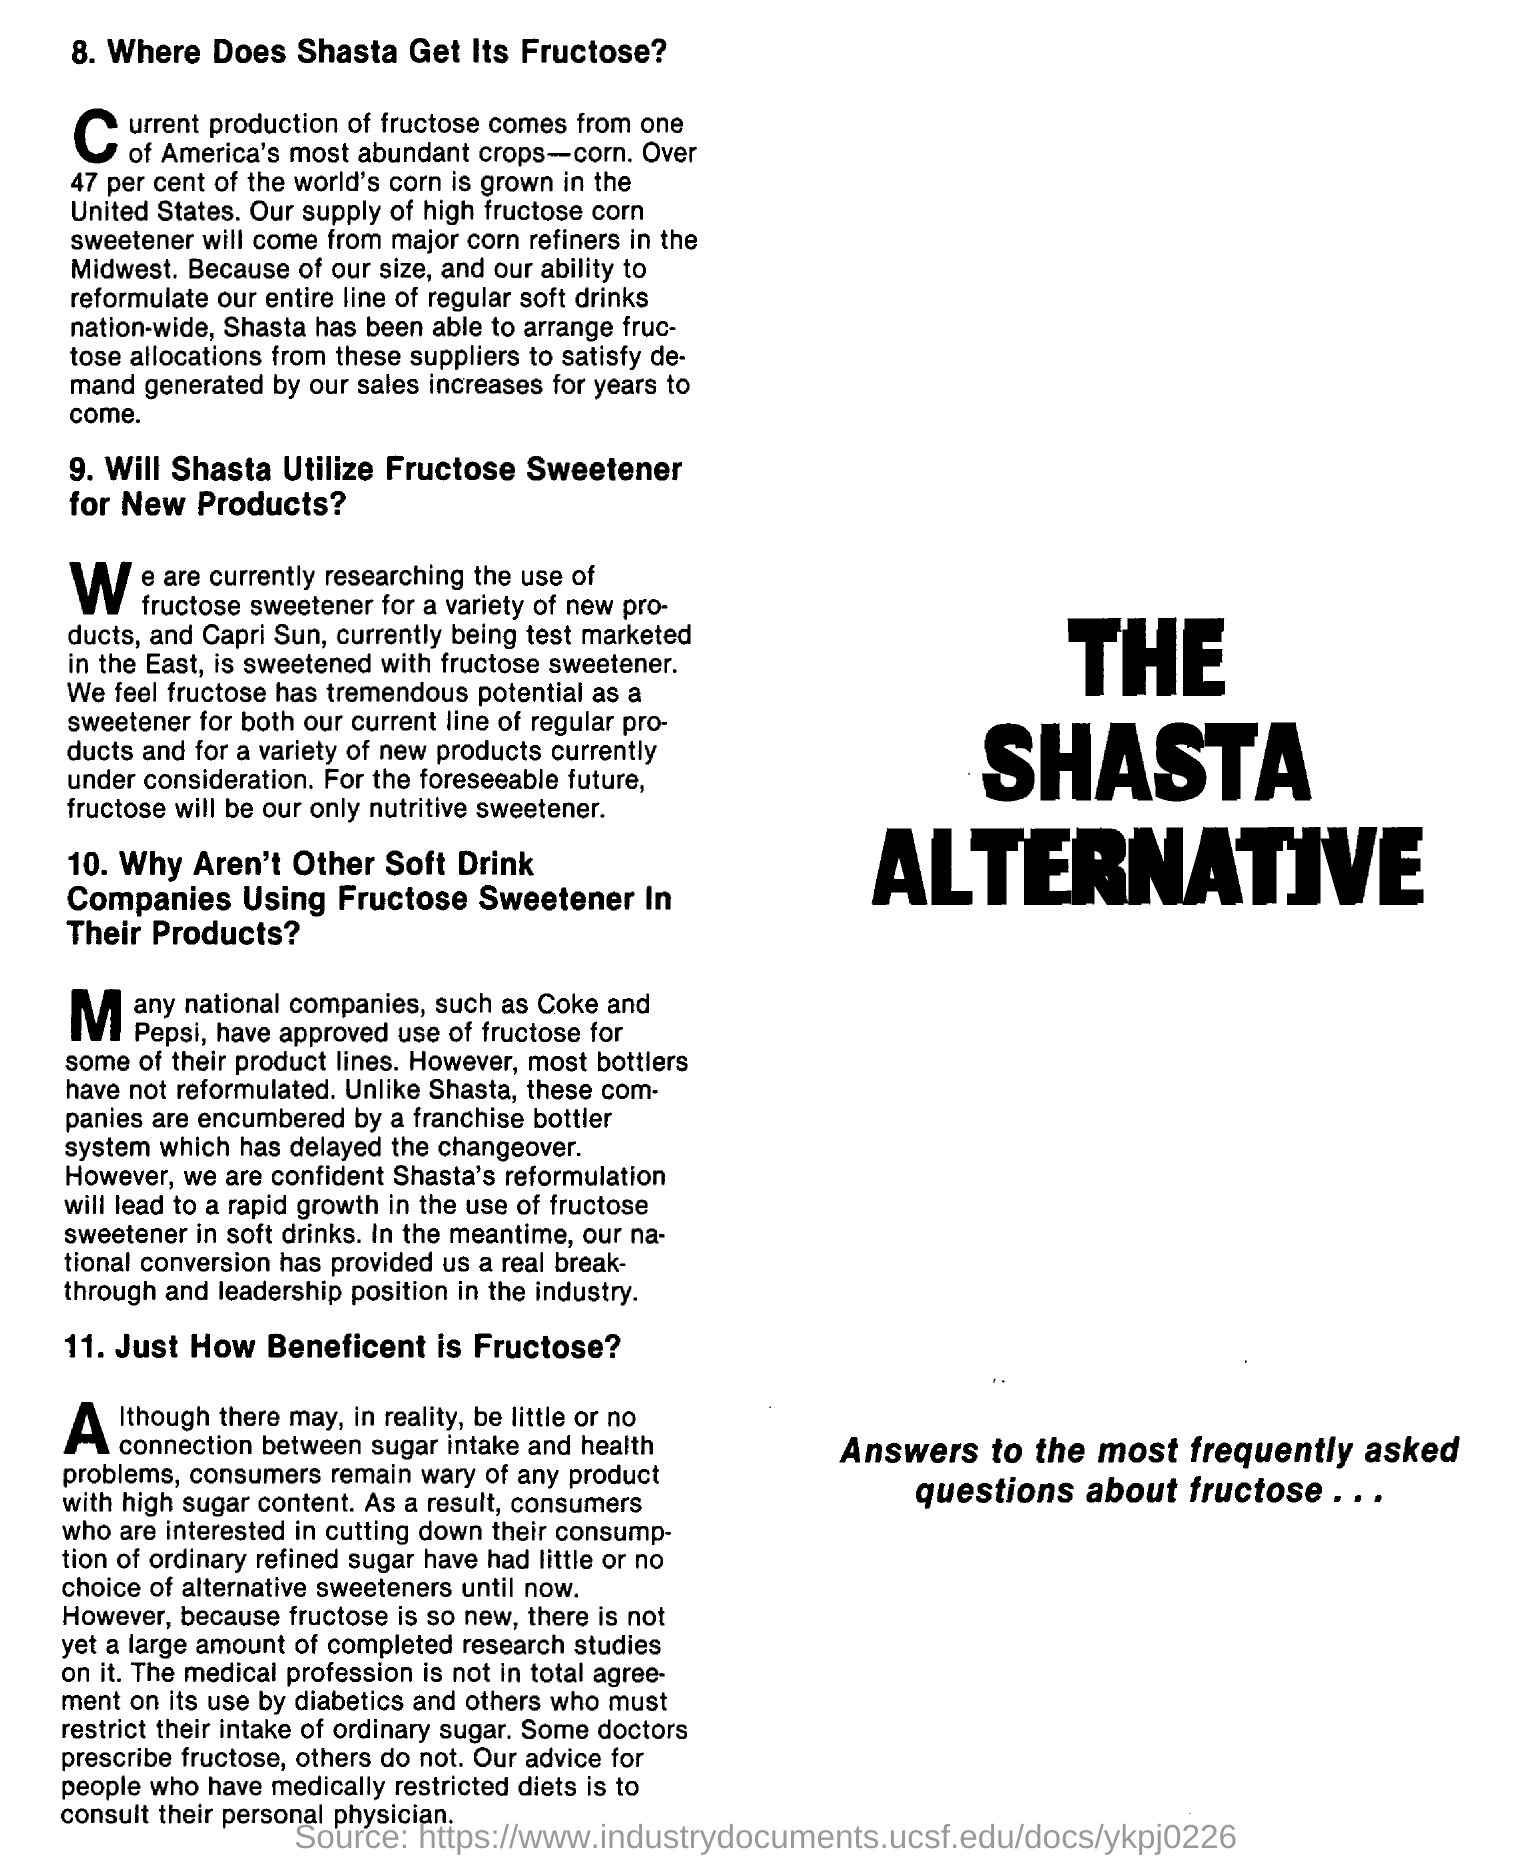Where does the high fructose corn will come from ?
Your response must be concise. Major corn refiners in the midwest. For foreseeable future what will be our only nutritive sweetener?
Offer a terse response. Fructose. What stops companies like coke and pepsi from using fructose widely?
Provide a succinct answer. Franchise bottler system. 